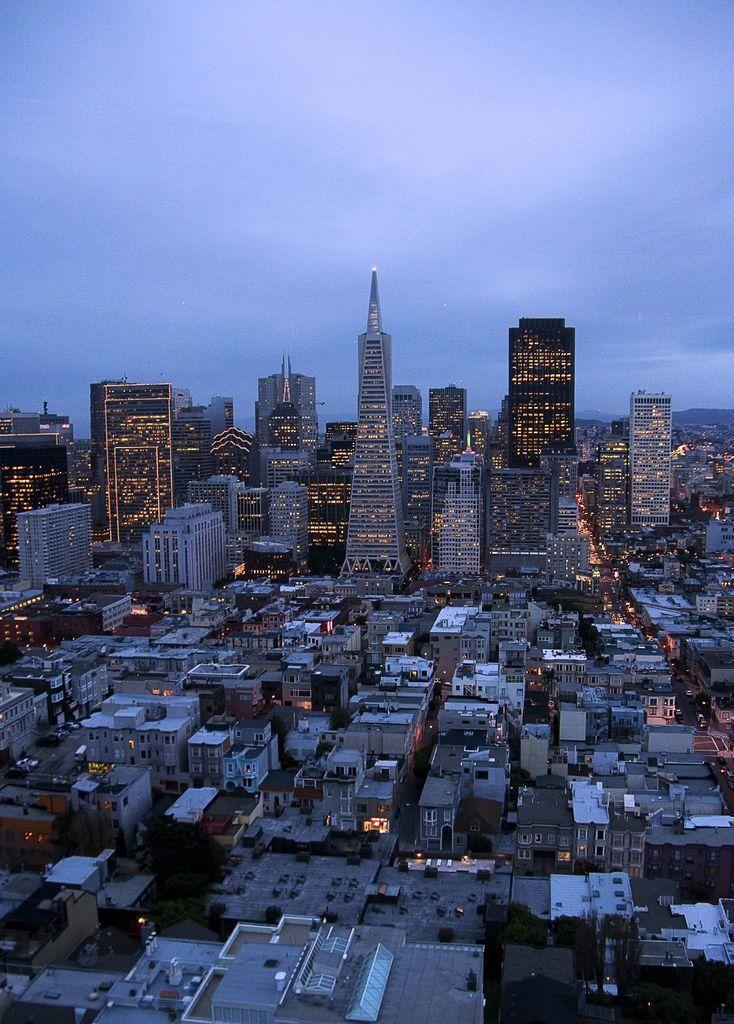How would you summarize this image in a sentence or two? This is an aerial view. In this picture we can see the buildings, lights, roofs, trees, roads, vehicles. At the top of the image we can see the clouds are present in the sky. 